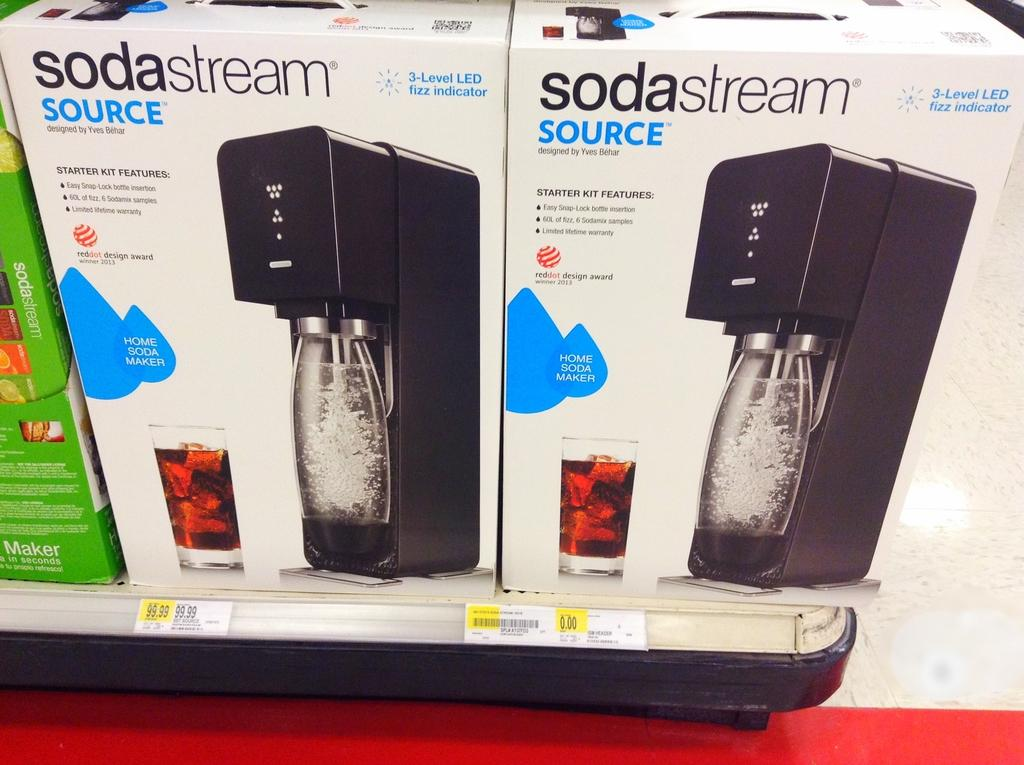Provide a one-sentence caption for the provided image. Soda stream source that is black and in a new box. 